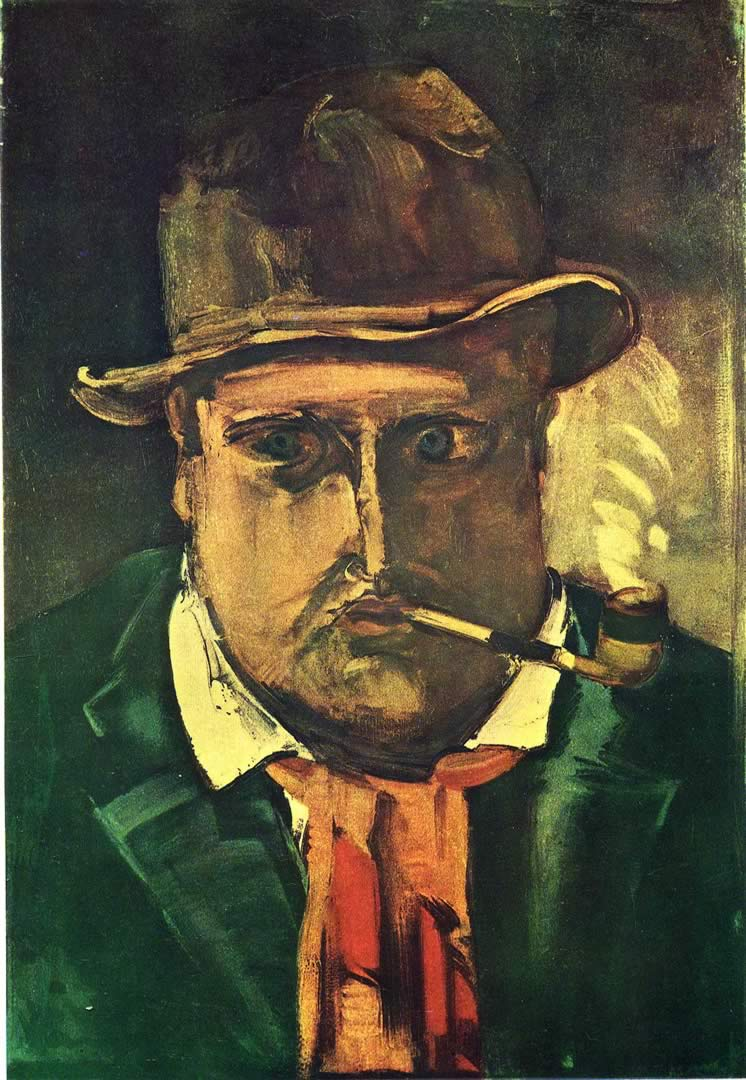What kind of emotions do you think the artist wanted to evoke with this painting? The artist likely intended to evoke a sense of introspection and perhaps even melancholy with this painting. The heavy use of dark greens and browns, combined with the exaggerated and somewhat brooding expression of the man, suggests a deep, contemplative mood. The man's fixed gaze and the act of smoking a pipe could signify a moment of personal reflection or a struggle with inner thoughts, a common theme in expressionist art. Why do you think the artist chose to depict the man with such exaggerated features? The exaggerated features are a characteristic trait of expressionism, a movement that aimed to depict not just the outward reality but the inner experiences and emotions of the subject. By distorting the man's features, the artist can convey deeper psychological states and emotions more vividly. This method allows viewers to engage with the painting on a more emotional and empathetic level, provoking a stronger emotional response. Can you imagine a backstory for this man? Who could he be and what might his life be like? Perhaps this man is a seasoned sailor, having spent many years navigating the harsh seas. The weariness in his eyes and the solemnity in his expression might tell a story of countless voyages and battles against the relentless elements. His hat and pipe are his trusted companions, providing comfort during moments of solitude. Every wrinkle and shadow on his face symbolizes a story, a memory of a life fraught with challenges and adventures, yet filled with an enduring spirit of resilience and hope. 